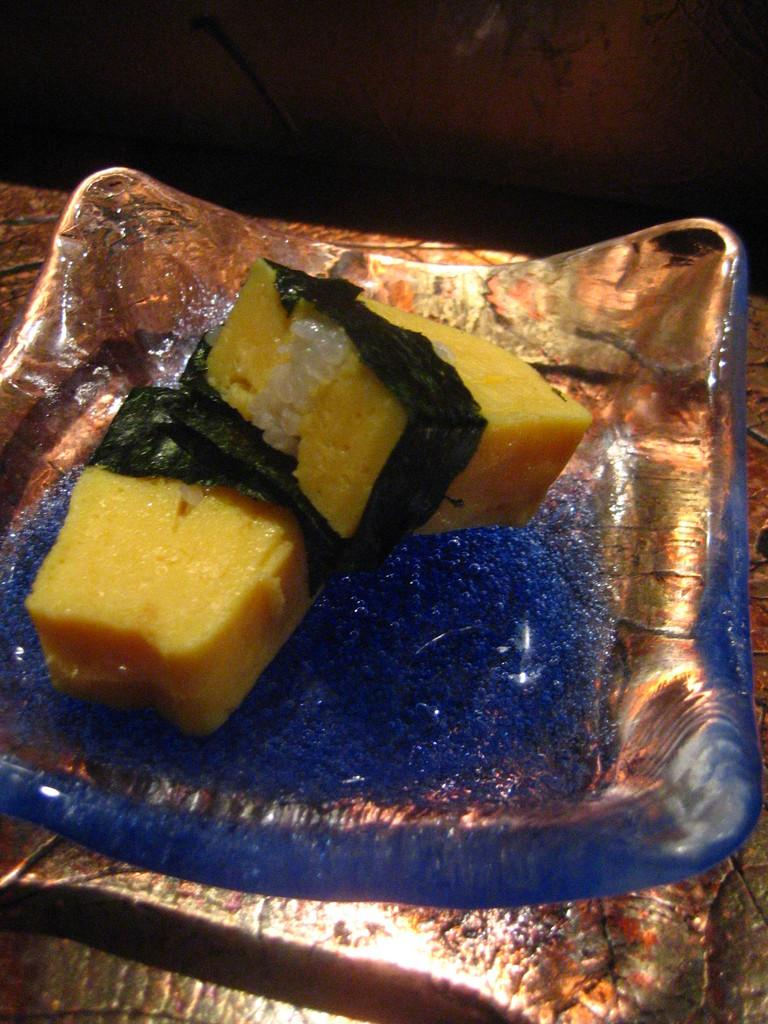What color is the liquid in the image? The liquid in the image is blue and has glitter in it. What objects are submerged in the liquid? There are two yellow sponge pieces in the liquid. What type of muscle can be seen flexing in the image? There is no muscle visible in the image; it features a blue glitter liquid with two yellow sponge pieces submerged in it. 